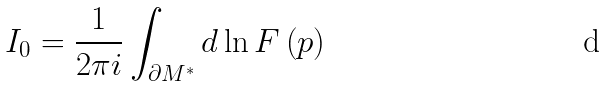<formula> <loc_0><loc_0><loc_500><loc_500>I _ { 0 } = \frac { 1 } { 2 \pi i } \int _ { \partial M ^ { \ast } } d \ln F \left ( p \right )</formula> 